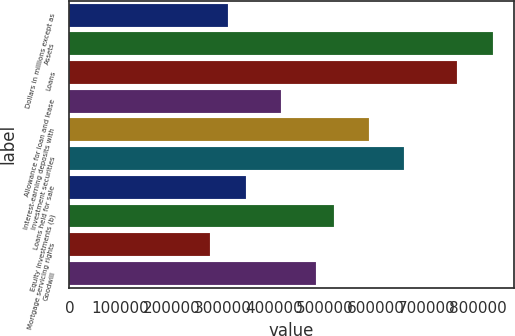Convert chart. <chart><loc_0><loc_0><loc_500><loc_500><bar_chart><fcel>Dollars in millions except as<fcel>Assets<fcel>Loans<fcel>Allowance for loan and lease<fcel>Interest-earning deposits with<fcel>Investment securities<fcel>Loans held for sale<fcel>Equity investments (b)<fcel>Mortgage servicing rights<fcel>Goodwill<nl><fcel>310566<fcel>828159<fcel>759146<fcel>414084<fcel>586615<fcel>655628<fcel>345072<fcel>517603<fcel>276060<fcel>483097<nl></chart> 